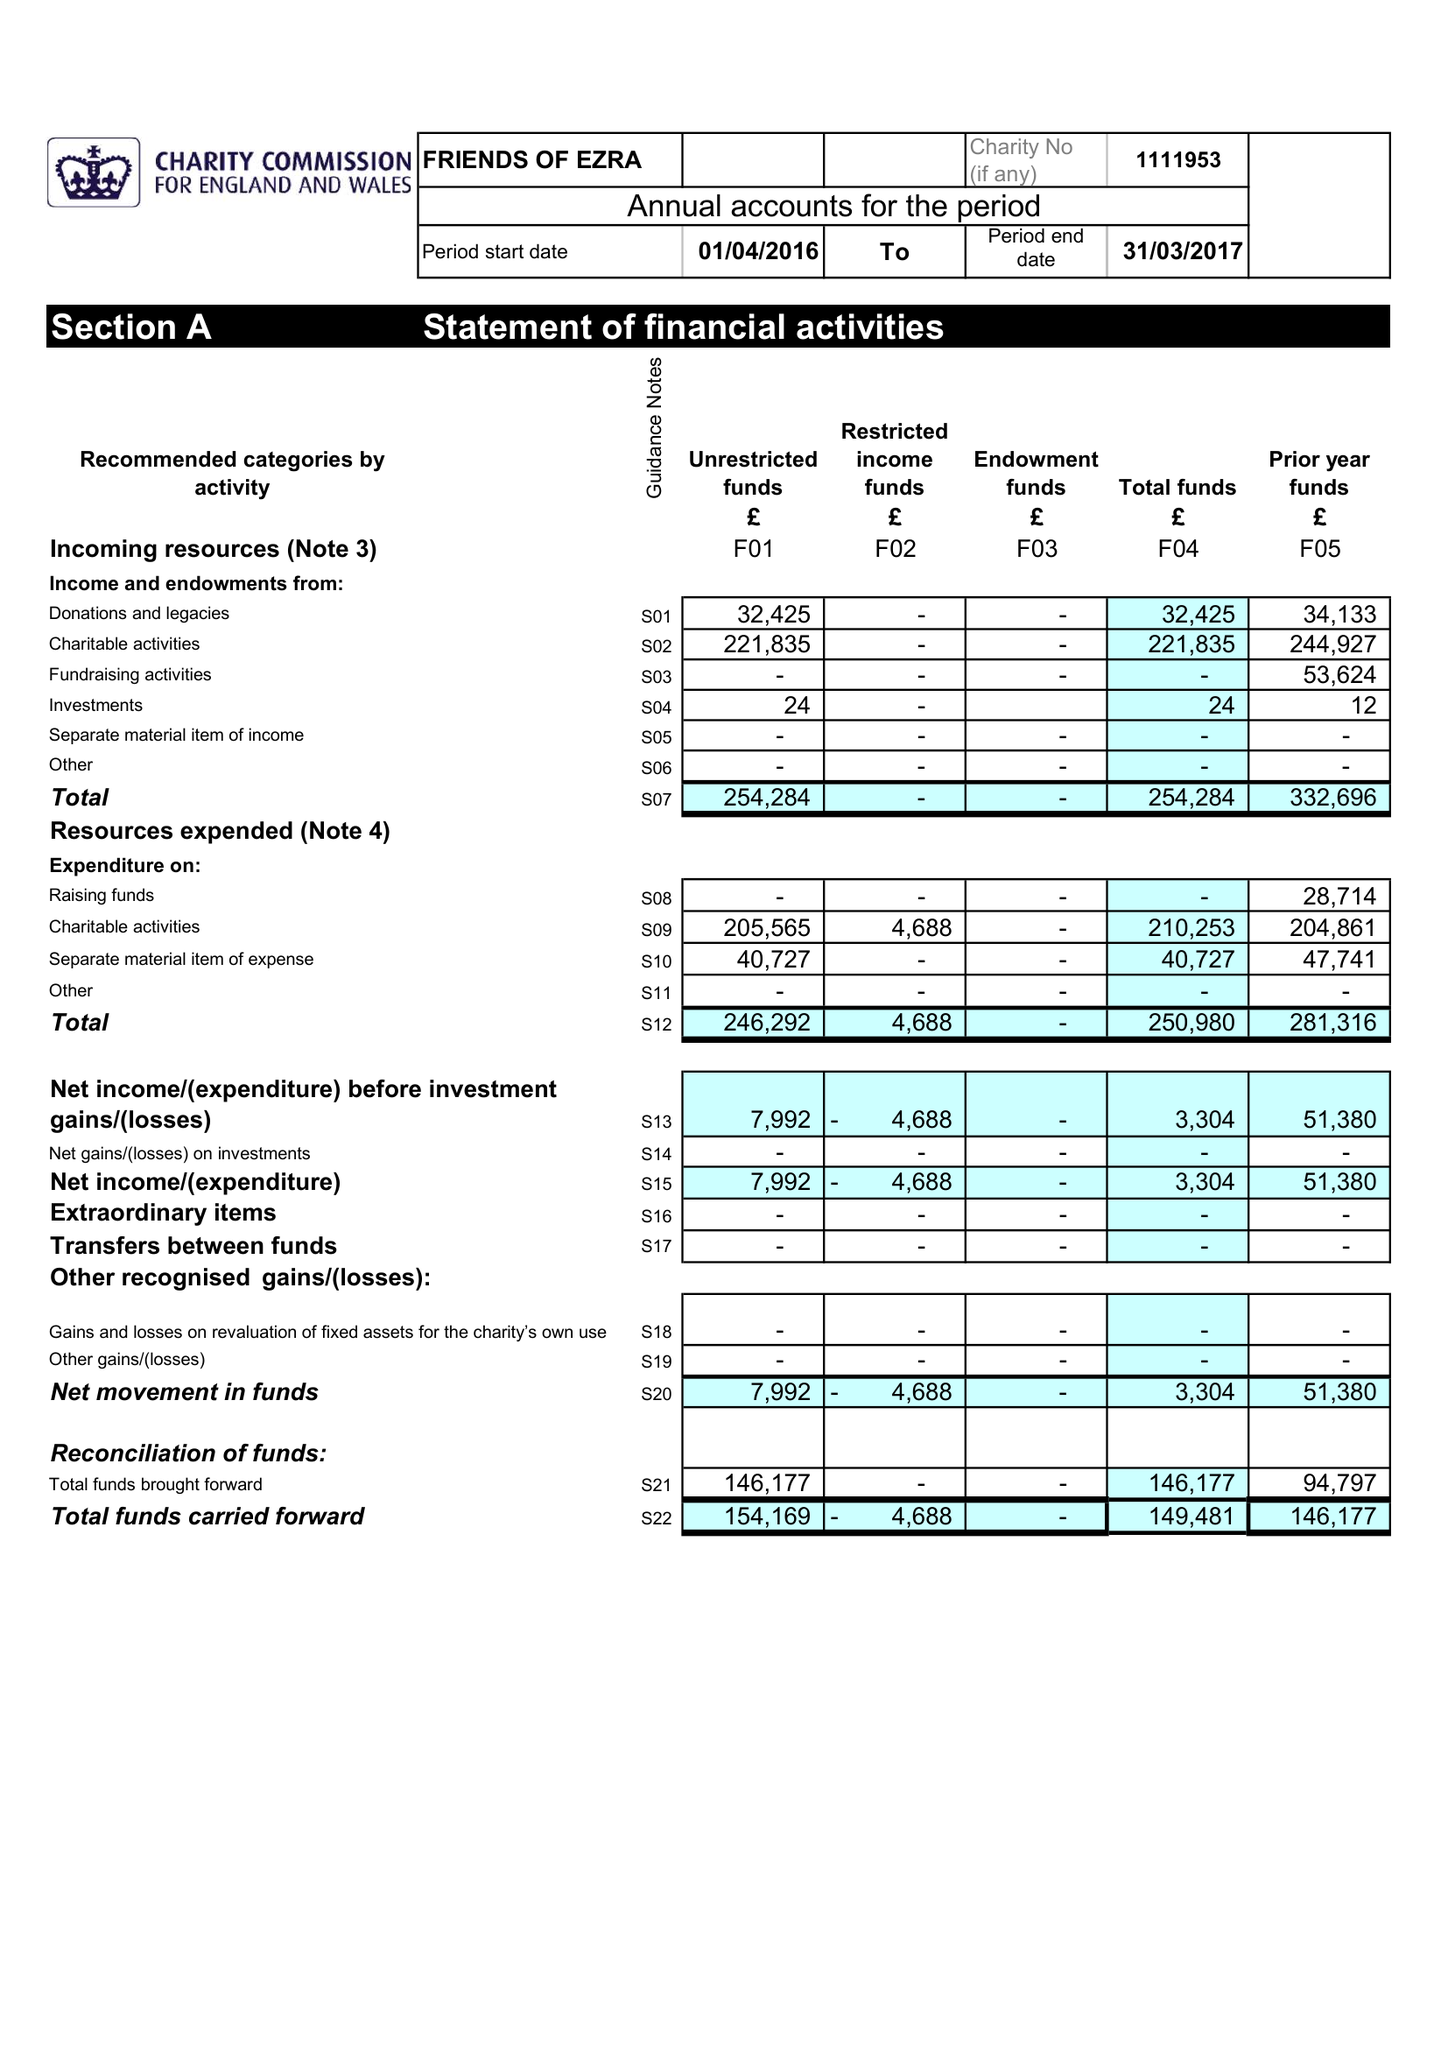What is the value for the address__postcode?
Answer the question using a single word or phrase. NW11 9BP 